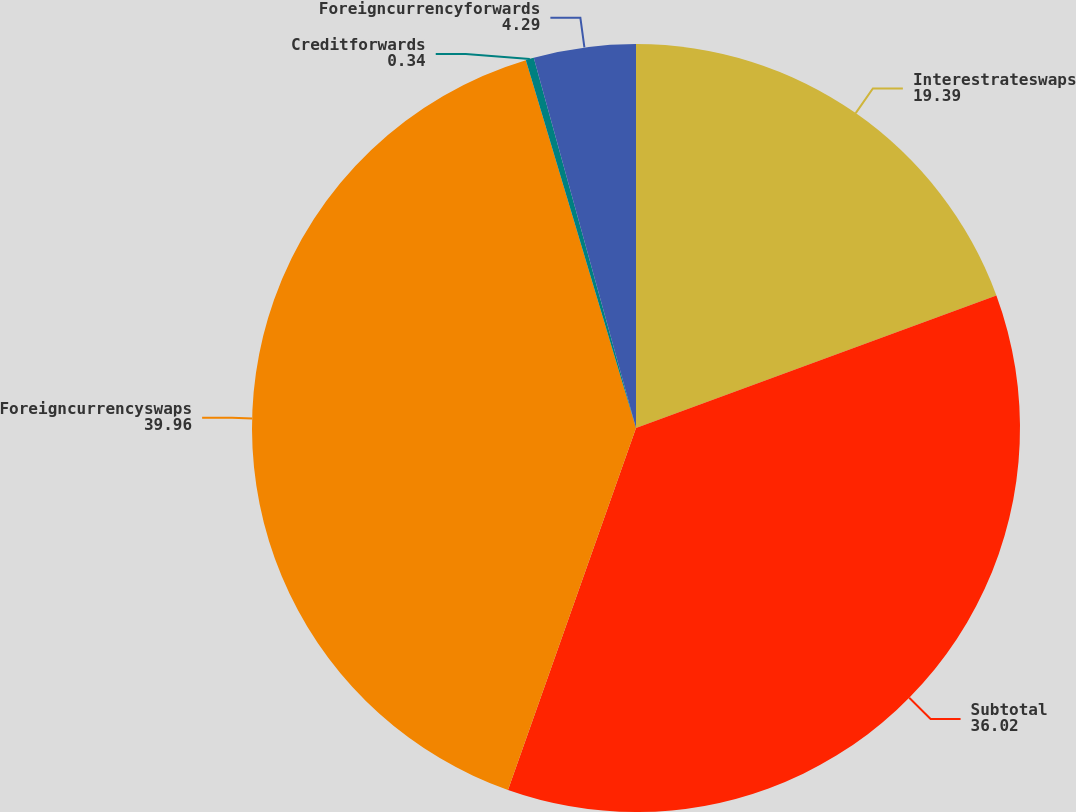<chart> <loc_0><loc_0><loc_500><loc_500><pie_chart><fcel>Interestrateswaps<fcel>Subtotal<fcel>Foreigncurrencyswaps<fcel>Creditforwards<fcel>Foreigncurrencyforwards<nl><fcel>19.39%<fcel>36.02%<fcel>39.96%<fcel>0.34%<fcel>4.29%<nl></chart> 